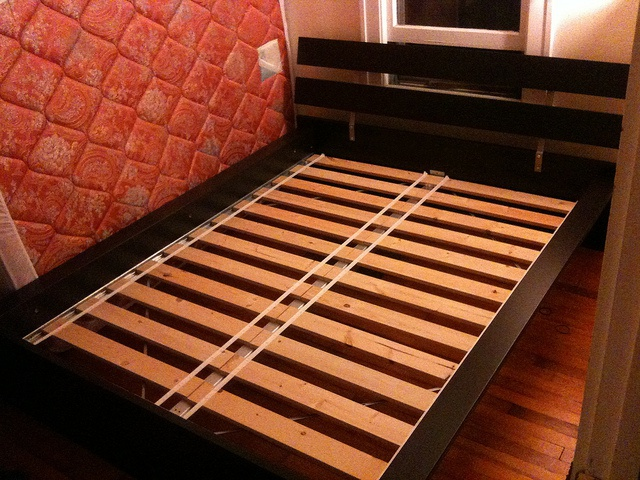Describe the objects in this image and their specific colors. I can see bed in tan, black, maroon, and salmon tones and bed in tan, brown, salmon, and red tones in this image. 